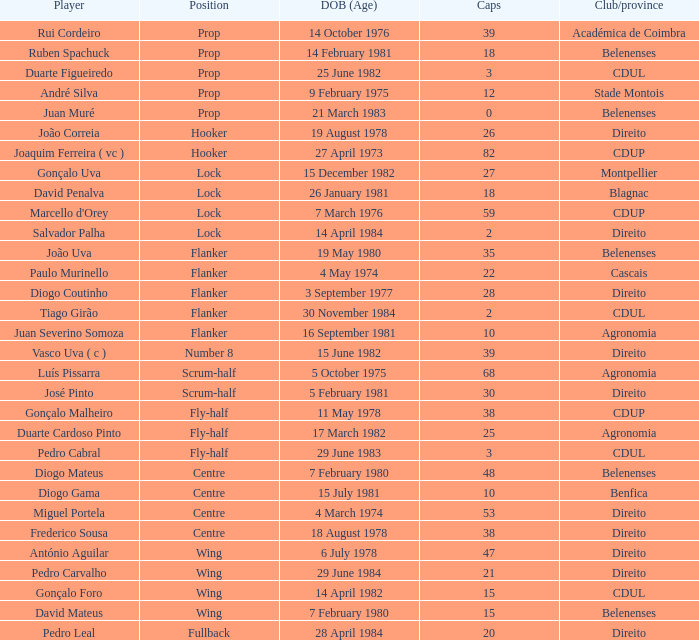Which player has a Position of fly-half, and a Caps of 3? Pedro Cabral. 